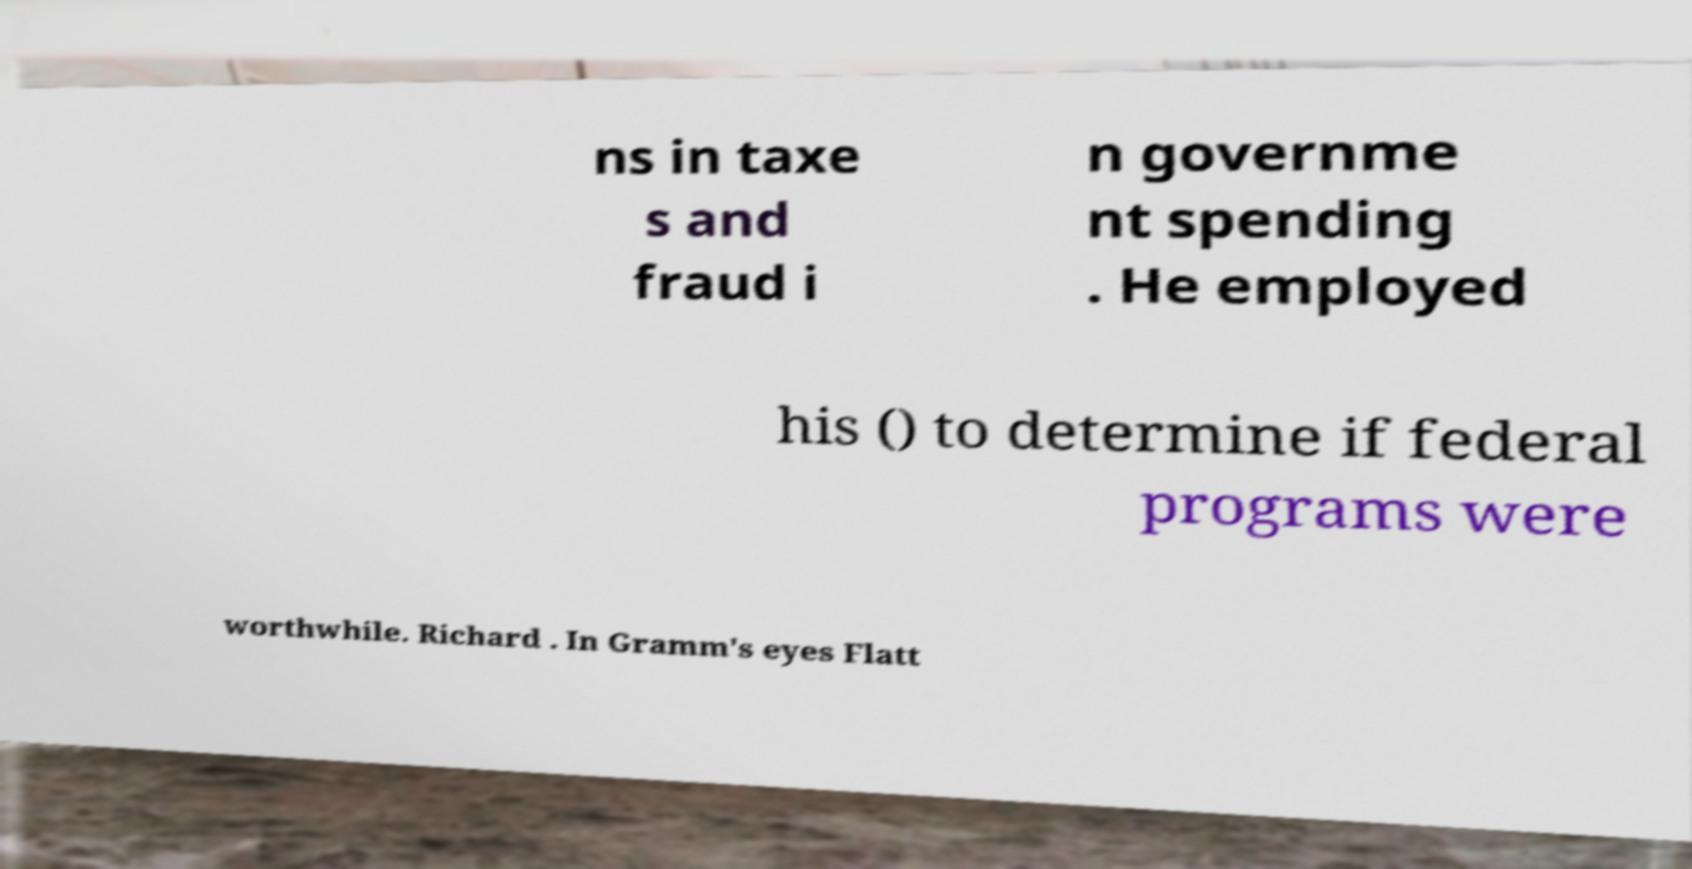For documentation purposes, I need the text within this image transcribed. Could you provide that? ns in taxe s and fraud i n governme nt spending . He employed his () to determine if federal programs were worthwhile. Richard . In Gramm's eyes Flatt 